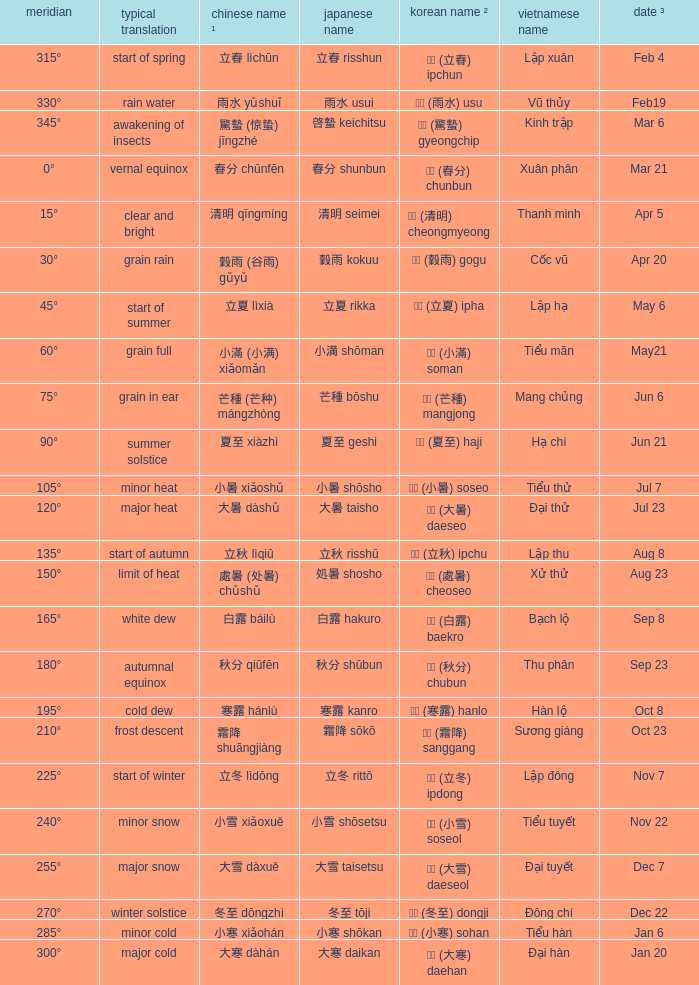Which Japanese name has a Korean name ² of 경칩 (驚蟄) gyeongchip? 啓蟄 keichitsu. 